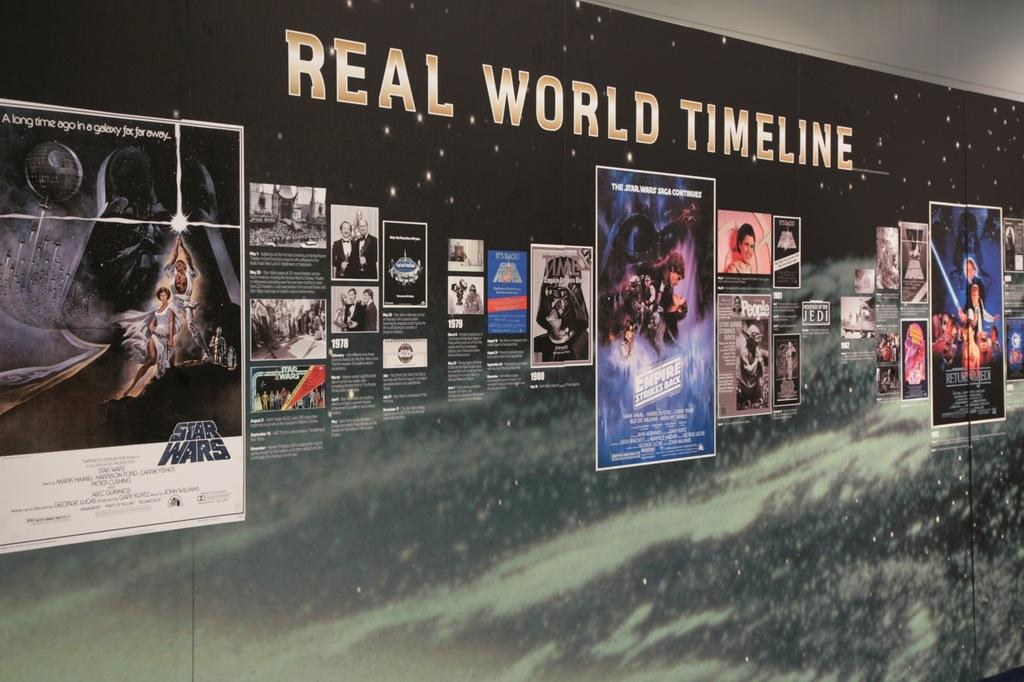<image>
Give a short and clear explanation of the subsequent image. The Real World Timeline is displayed on a starry backdrop. 